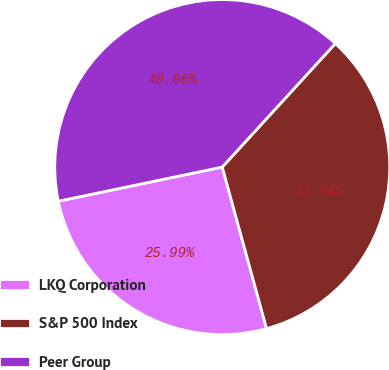<chart> <loc_0><loc_0><loc_500><loc_500><pie_chart><fcel>LKQ Corporation<fcel>S&P 500 Index<fcel>Peer Group<nl><fcel>25.99%<fcel>33.94%<fcel>40.06%<nl></chart> 